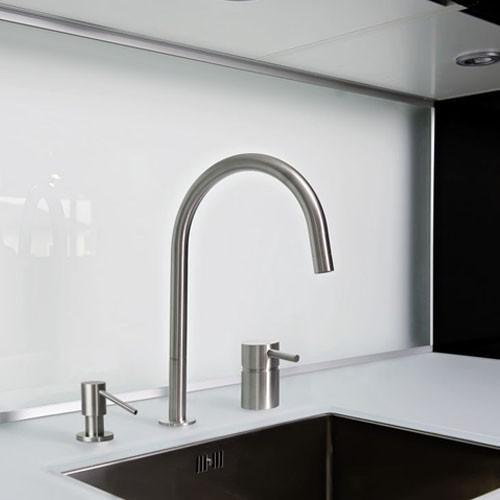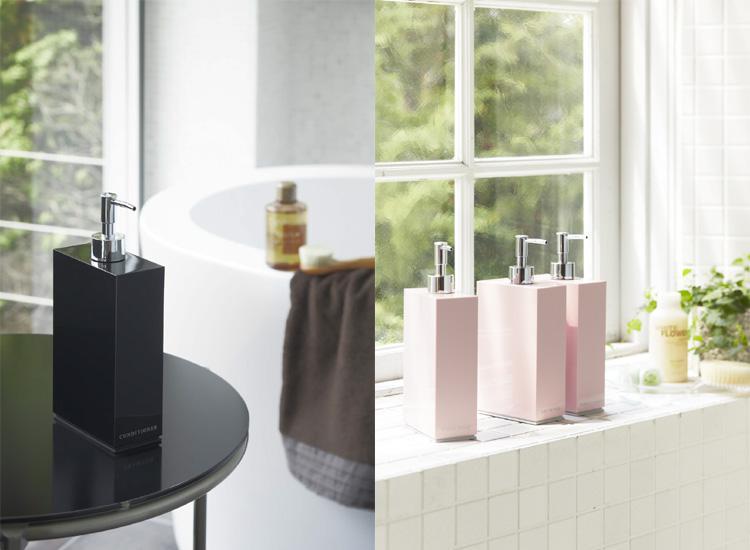The first image is the image on the left, the second image is the image on the right. Assess this claim about the two images: "At least one soap dispenser has a spout pointing towards the left.". Correct or not? Answer yes or no. No. The first image is the image on the left, the second image is the image on the right. Analyze the images presented: Is the assertion "Multiple pump-top dispensers can be seen sitting on top of surfaces instead of mounted." valid? Answer yes or no. Yes. 